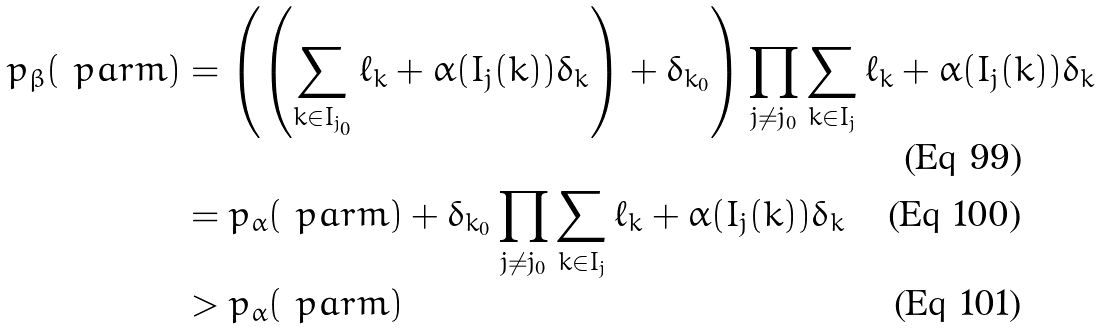<formula> <loc_0><loc_0><loc_500><loc_500>p _ { \beta } ( \ p a r m ) & = \left ( \left ( \sum _ { k \in I _ { j _ { 0 } } } \ell _ { k } + \alpha ( I _ { j } ( k ) ) \delta _ { k } \right ) + \delta _ { k _ { 0 } } \right ) \prod _ { j \neq j _ { 0 } } \sum _ { k \in I _ { j } } \ell _ { k } + \alpha ( I _ { j } ( k ) ) \delta _ { k } \\ & = p _ { \alpha } ( \ p a r m ) + \delta _ { k _ { 0 } } \prod _ { j \neq j _ { 0 } } \sum _ { k \in I _ { j } } \ell _ { k } + \alpha ( I _ { j } ( k ) ) \delta _ { k } \\ & > p _ { \alpha } ( \ p a r m )</formula> 